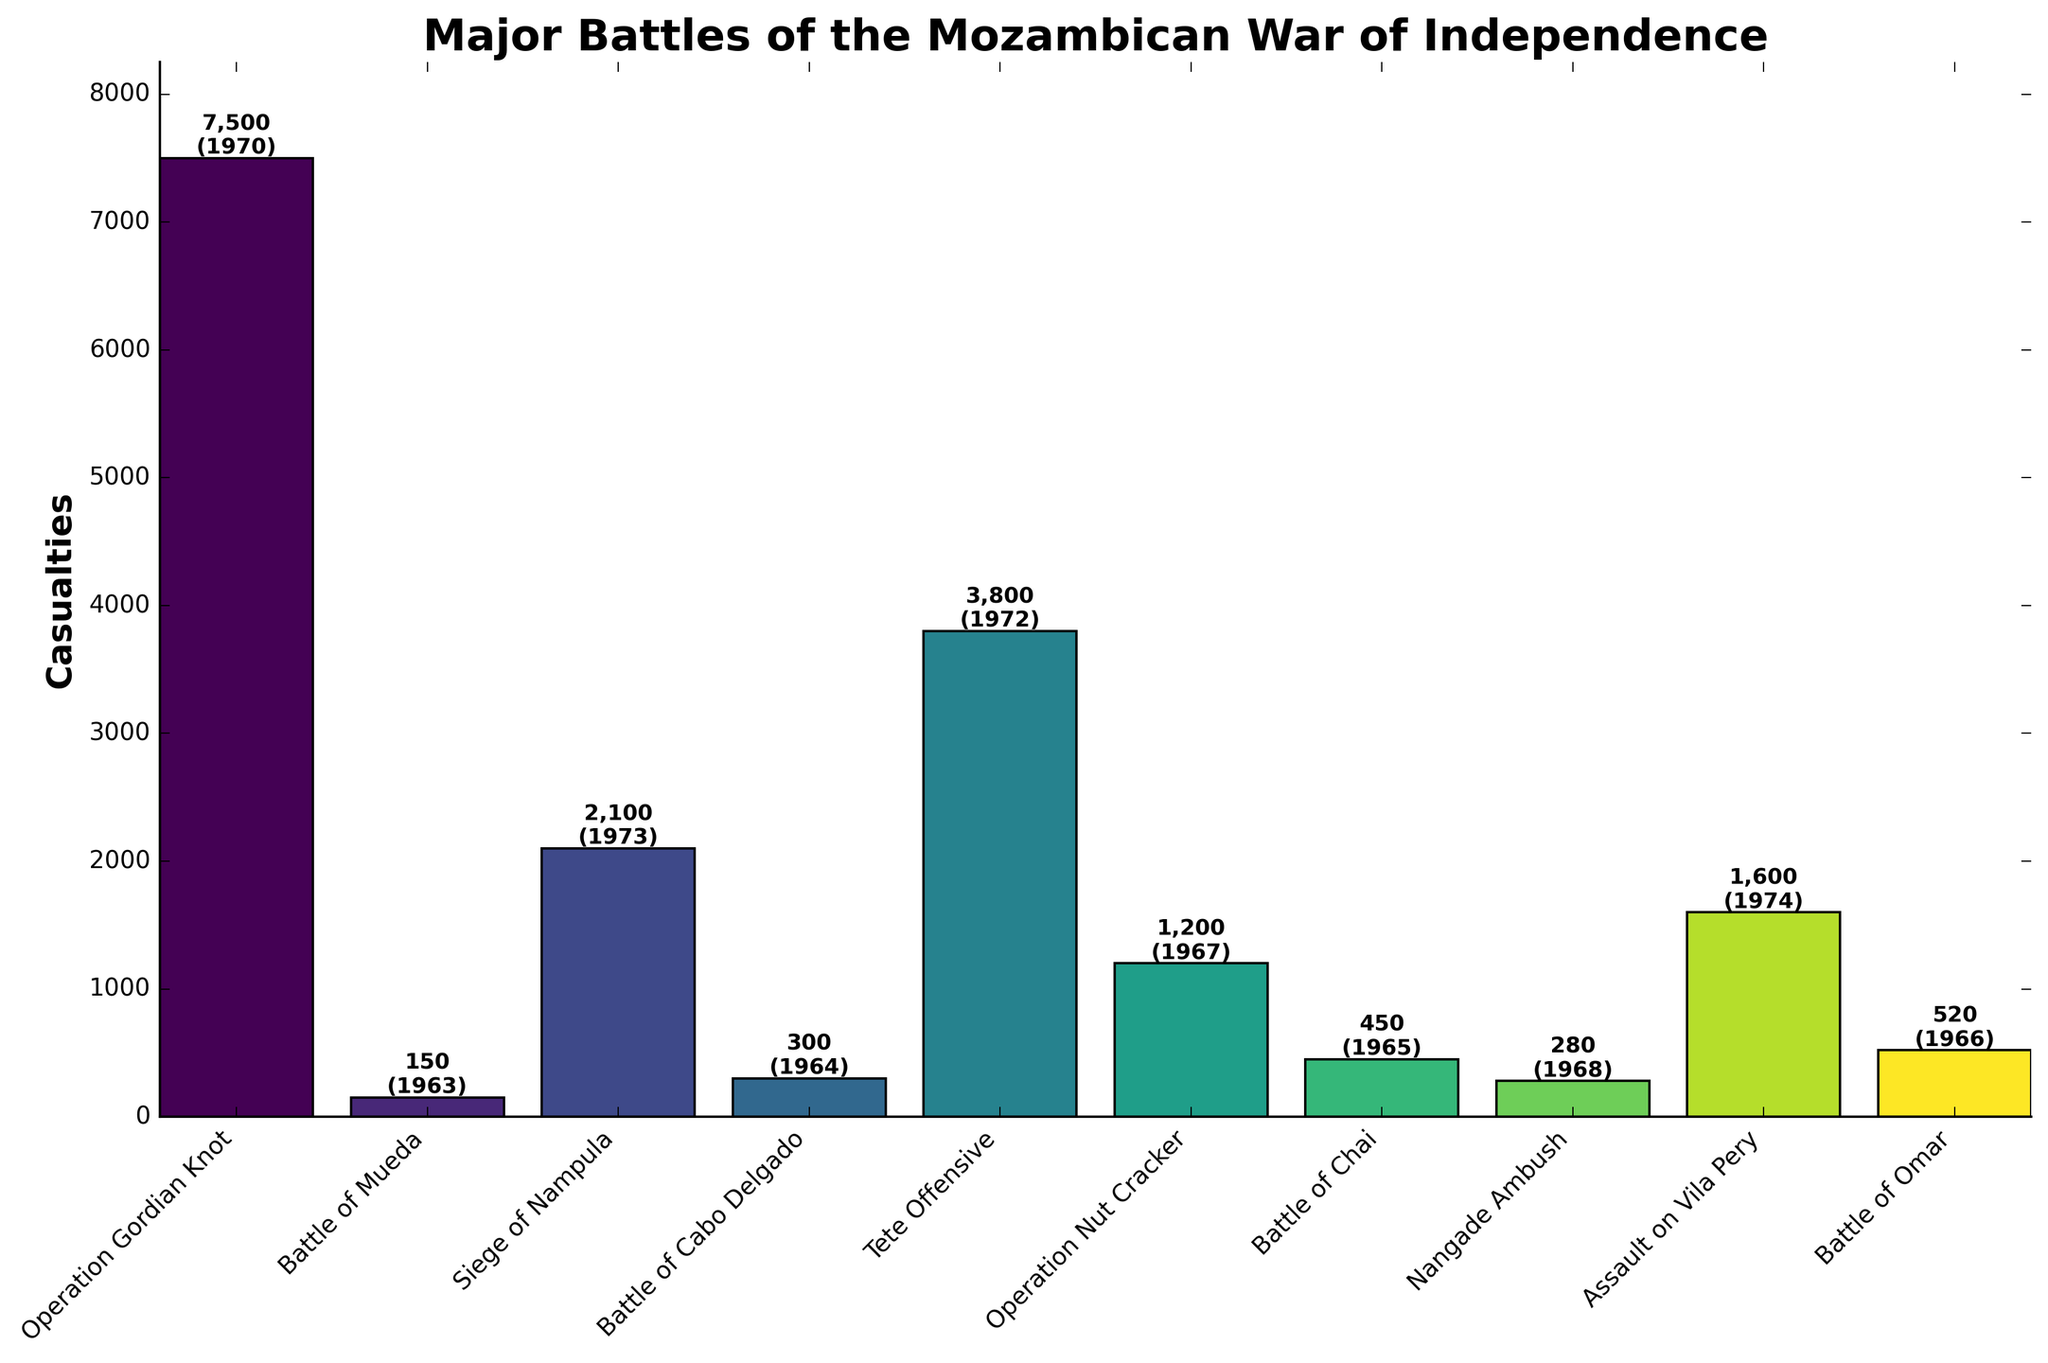Which battle had the highest number of casualties? To determine the battle with the highest number of casualties, look for the tallest bar in the bar chart. The tallest bar represents Operation Gordian Knot with 7,500 casualties.
Answer: Operation Gordian Knot How many battles had more than 1,000 casualties? To find the number of battles with casualties above 1,000, count the number of bars that exceed the 1,000 mark on the y-axis. The battles are Operation Gordian Knot, Siege of Nampula, Tete Offensive, Operation Nut Cracker, Assault on Vila Pery, and Battle of Omar, which totals to 6.
Answer: 6 What's the sum of casualties for the Siege of Nampula and the Tete Offensive? To get the total number of casualties for the Siege of Nampula and the Tete Offensive, add their respective casualties together: 2,100 (Siege of Nampula) + 3,800 (Tete Offensive) = 5,900.
Answer: 5,900 Which battle in the 1960s had the highest casualties? To find the 1960s battle with the highest casualties, identify the bars labeled with years in the 1960s and compare their heights. Operation Nut Cracker (1,200 in 1967) had the highest casualties among those battles.
Answer: Operation Nut Cracker What's the average number of casualties for battles in 1970 and later? To calculate the average number of casualties for battles in 1970 and later, sum the casualties for Operation Gordian Knot (7,500), Siege of Nampula (2,100), Tete Offensive (3,800), and Assault on Vila Pery (1,600), then divide by the number of battles (4): (7,500 + 2,100 + 3,800 + 1,600)/4 = 3,750.
Answer: 3,750 Which battle had fewer casualties: Battle of Mueda or Battle of Cabo Delgado? To determine which battle had fewer casualties, compare the heights of the bars for Battle of Mueda (150) and Battle of Cabo Delgado (300). The Battle of Mueda had fewer casualties.
Answer: Battle of Mueda What is the difference in casualties between Operation Gordian Knot and the Assault on Vila Pery? To find the difference in casualties, subtract the casualties of the Assault on Vila Pery (1,600) from Operation Gordian Knot (7,500): 7,500 - 1,600 = 5,900.
Answer: 5,900 What is the combined total of casualties for all battles that took place in 1968 and 1972? To find the combined total casualties for battles in 1968 and 1972, add the casualties for those years: Nangade Ambush (280) in 1968 and Tete Offensive (3,800) in 1972. The total is 280 + 3,800 = 4,080.
Answer: 4,080 How many battles were fought before 1970? To find the number of battles fought before 1970, count the bars with years before 1970: Battle of Mueda (1963), Battle of Cabo Delgado (1964), Battle of Chai (1965), Battle of Omar (1966), Operation Nut Cracker (1967), and Nangade Ambush (1968), totaling 6 battles.
Answer: 6 